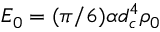Convert formula to latex. <formula><loc_0><loc_0><loc_500><loc_500>E _ { 0 } = ( \pi / 6 ) \alpha d _ { c } ^ { 4 } \rho _ { 0 }</formula> 